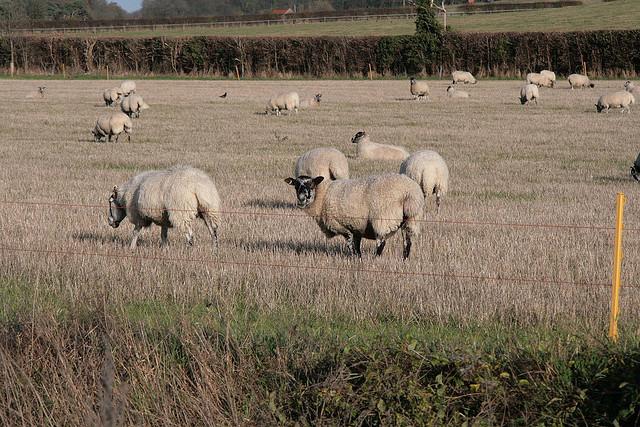Are all the sheep looking at the photographer?
Write a very short answer. No. How many sheep are in the picture?
Concise answer only. 20. What is the fence made from?
Short answer required. Wire. Are those sheep wild?
Write a very short answer. No. What animal is behind the fence?
Give a very brief answer. Sheep. How many sheep are there?
Short answer required. 20. Is the grass green?
Concise answer only. No. How many sheep?
Quick response, please. 22. 